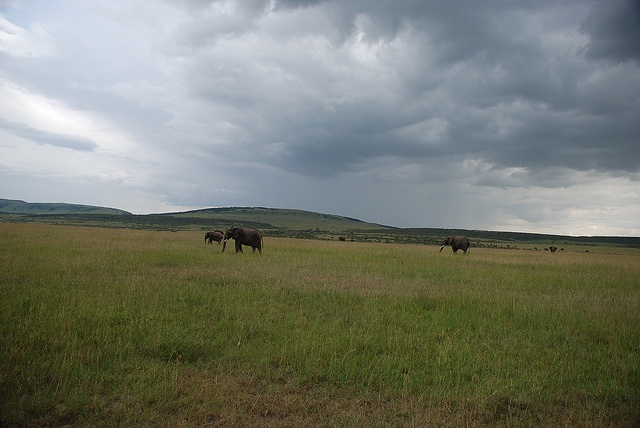Describe the objects in this image and their specific colors. I can see elephant in darkgray, black, darkgreen, and gray tones, elephant in darkgray, black, darkgreen, and gray tones, elephant in darkgray, black, and gray tones, elephant in darkgray, black, and gray tones, and elephant in black, gray, and darkgray tones in this image. 